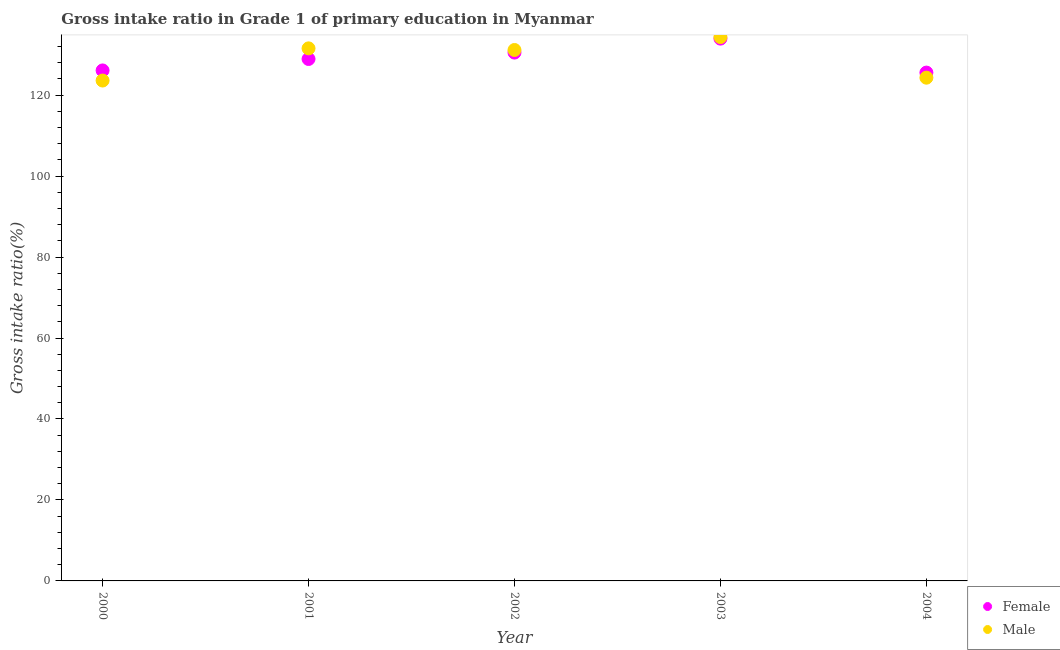What is the gross intake ratio(male) in 2002?
Keep it short and to the point. 131.15. Across all years, what is the maximum gross intake ratio(female)?
Ensure brevity in your answer.  133.96. Across all years, what is the minimum gross intake ratio(male)?
Offer a terse response. 123.61. In which year was the gross intake ratio(male) minimum?
Offer a very short reply. 2000. What is the total gross intake ratio(female) in the graph?
Offer a terse response. 645.09. What is the difference between the gross intake ratio(female) in 2000 and that in 2003?
Your answer should be very brief. -7.86. What is the difference between the gross intake ratio(male) in 2001 and the gross intake ratio(female) in 2002?
Make the answer very short. 1.04. What is the average gross intake ratio(male) per year?
Your answer should be very brief. 129. In the year 2000, what is the difference between the gross intake ratio(male) and gross intake ratio(female)?
Your answer should be compact. -2.5. What is the ratio of the gross intake ratio(female) in 2001 to that in 2003?
Provide a succinct answer. 0.96. Is the difference between the gross intake ratio(female) in 2001 and 2004 greater than the difference between the gross intake ratio(male) in 2001 and 2004?
Your response must be concise. No. What is the difference between the highest and the second highest gross intake ratio(female)?
Offer a very short reply. 3.45. What is the difference between the highest and the lowest gross intake ratio(male)?
Make the answer very short. 10.74. In how many years, is the gross intake ratio(male) greater than the average gross intake ratio(male) taken over all years?
Your answer should be compact. 3. Is the sum of the gross intake ratio(male) in 2000 and 2003 greater than the maximum gross intake ratio(female) across all years?
Give a very brief answer. Yes. Is the gross intake ratio(male) strictly greater than the gross intake ratio(female) over the years?
Provide a succinct answer. No. Is the gross intake ratio(male) strictly less than the gross intake ratio(female) over the years?
Make the answer very short. No. What is the difference between two consecutive major ticks on the Y-axis?
Keep it short and to the point. 20. Are the values on the major ticks of Y-axis written in scientific E-notation?
Give a very brief answer. No. Does the graph contain any zero values?
Your response must be concise. No. Does the graph contain grids?
Your answer should be very brief. No. How are the legend labels stacked?
Your answer should be compact. Vertical. What is the title of the graph?
Ensure brevity in your answer.  Gross intake ratio in Grade 1 of primary education in Myanmar. Does "Depositors" appear as one of the legend labels in the graph?
Your answer should be very brief. No. What is the label or title of the Y-axis?
Your answer should be very brief. Gross intake ratio(%). What is the Gross intake ratio(%) in Female in 2000?
Make the answer very short. 126.11. What is the Gross intake ratio(%) of Male in 2000?
Offer a very short reply. 123.61. What is the Gross intake ratio(%) in Female in 2001?
Ensure brevity in your answer.  128.93. What is the Gross intake ratio(%) of Male in 2001?
Your answer should be very brief. 131.56. What is the Gross intake ratio(%) of Female in 2002?
Ensure brevity in your answer.  130.52. What is the Gross intake ratio(%) in Male in 2002?
Provide a succinct answer. 131.15. What is the Gross intake ratio(%) in Female in 2003?
Ensure brevity in your answer.  133.96. What is the Gross intake ratio(%) in Male in 2003?
Your answer should be compact. 134.35. What is the Gross intake ratio(%) in Female in 2004?
Your response must be concise. 125.57. What is the Gross intake ratio(%) of Male in 2004?
Your response must be concise. 124.32. Across all years, what is the maximum Gross intake ratio(%) in Female?
Provide a succinct answer. 133.96. Across all years, what is the maximum Gross intake ratio(%) of Male?
Provide a short and direct response. 134.35. Across all years, what is the minimum Gross intake ratio(%) of Female?
Offer a very short reply. 125.57. Across all years, what is the minimum Gross intake ratio(%) of Male?
Provide a succinct answer. 123.61. What is the total Gross intake ratio(%) of Female in the graph?
Offer a terse response. 645.09. What is the total Gross intake ratio(%) in Male in the graph?
Provide a short and direct response. 644.98. What is the difference between the Gross intake ratio(%) of Female in 2000 and that in 2001?
Ensure brevity in your answer.  -2.83. What is the difference between the Gross intake ratio(%) of Male in 2000 and that in 2001?
Ensure brevity in your answer.  -7.95. What is the difference between the Gross intake ratio(%) of Female in 2000 and that in 2002?
Your answer should be very brief. -4.41. What is the difference between the Gross intake ratio(%) of Male in 2000 and that in 2002?
Give a very brief answer. -7.55. What is the difference between the Gross intake ratio(%) of Female in 2000 and that in 2003?
Offer a terse response. -7.86. What is the difference between the Gross intake ratio(%) of Male in 2000 and that in 2003?
Give a very brief answer. -10.74. What is the difference between the Gross intake ratio(%) in Female in 2000 and that in 2004?
Give a very brief answer. 0.53. What is the difference between the Gross intake ratio(%) in Male in 2000 and that in 2004?
Ensure brevity in your answer.  -0.71. What is the difference between the Gross intake ratio(%) of Female in 2001 and that in 2002?
Ensure brevity in your answer.  -1.58. What is the difference between the Gross intake ratio(%) of Male in 2001 and that in 2002?
Provide a short and direct response. 0.4. What is the difference between the Gross intake ratio(%) in Female in 2001 and that in 2003?
Provide a succinct answer. -5.03. What is the difference between the Gross intake ratio(%) in Male in 2001 and that in 2003?
Offer a terse response. -2.8. What is the difference between the Gross intake ratio(%) in Female in 2001 and that in 2004?
Your answer should be compact. 3.36. What is the difference between the Gross intake ratio(%) in Male in 2001 and that in 2004?
Your response must be concise. 7.24. What is the difference between the Gross intake ratio(%) of Female in 2002 and that in 2003?
Give a very brief answer. -3.45. What is the difference between the Gross intake ratio(%) in Male in 2002 and that in 2003?
Keep it short and to the point. -3.2. What is the difference between the Gross intake ratio(%) of Female in 2002 and that in 2004?
Keep it short and to the point. 4.94. What is the difference between the Gross intake ratio(%) in Male in 2002 and that in 2004?
Ensure brevity in your answer.  6.84. What is the difference between the Gross intake ratio(%) of Female in 2003 and that in 2004?
Your answer should be compact. 8.39. What is the difference between the Gross intake ratio(%) in Male in 2003 and that in 2004?
Offer a very short reply. 10.04. What is the difference between the Gross intake ratio(%) of Female in 2000 and the Gross intake ratio(%) of Male in 2001?
Your response must be concise. -5.45. What is the difference between the Gross intake ratio(%) in Female in 2000 and the Gross intake ratio(%) in Male in 2002?
Ensure brevity in your answer.  -5.05. What is the difference between the Gross intake ratio(%) in Female in 2000 and the Gross intake ratio(%) in Male in 2003?
Your answer should be compact. -8.25. What is the difference between the Gross intake ratio(%) in Female in 2000 and the Gross intake ratio(%) in Male in 2004?
Give a very brief answer. 1.79. What is the difference between the Gross intake ratio(%) of Female in 2001 and the Gross intake ratio(%) of Male in 2002?
Offer a very short reply. -2.22. What is the difference between the Gross intake ratio(%) of Female in 2001 and the Gross intake ratio(%) of Male in 2003?
Provide a succinct answer. -5.42. What is the difference between the Gross intake ratio(%) in Female in 2001 and the Gross intake ratio(%) in Male in 2004?
Your answer should be very brief. 4.62. What is the difference between the Gross intake ratio(%) of Female in 2002 and the Gross intake ratio(%) of Male in 2003?
Offer a very short reply. -3.84. What is the difference between the Gross intake ratio(%) in Female in 2002 and the Gross intake ratio(%) in Male in 2004?
Provide a succinct answer. 6.2. What is the difference between the Gross intake ratio(%) in Female in 2003 and the Gross intake ratio(%) in Male in 2004?
Provide a succinct answer. 9.65. What is the average Gross intake ratio(%) in Female per year?
Offer a terse response. 129.02. What is the average Gross intake ratio(%) in Male per year?
Give a very brief answer. 129. In the year 2000, what is the difference between the Gross intake ratio(%) in Female and Gross intake ratio(%) in Male?
Provide a succinct answer. 2.5. In the year 2001, what is the difference between the Gross intake ratio(%) in Female and Gross intake ratio(%) in Male?
Ensure brevity in your answer.  -2.62. In the year 2002, what is the difference between the Gross intake ratio(%) of Female and Gross intake ratio(%) of Male?
Your response must be concise. -0.64. In the year 2003, what is the difference between the Gross intake ratio(%) in Female and Gross intake ratio(%) in Male?
Provide a succinct answer. -0.39. In the year 2004, what is the difference between the Gross intake ratio(%) of Female and Gross intake ratio(%) of Male?
Your answer should be very brief. 1.26. What is the ratio of the Gross intake ratio(%) in Female in 2000 to that in 2001?
Offer a terse response. 0.98. What is the ratio of the Gross intake ratio(%) of Male in 2000 to that in 2001?
Give a very brief answer. 0.94. What is the ratio of the Gross intake ratio(%) of Female in 2000 to that in 2002?
Your answer should be very brief. 0.97. What is the ratio of the Gross intake ratio(%) of Male in 2000 to that in 2002?
Ensure brevity in your answer.  0.94. What is the ratio of the Gross intake ratio(%) in Female in 2000 to that in 2003?
Your response must be concise. 0.94. What is the ratio of the Gross intake ratio(%) in Male in 2000 to that in 2003?
Offer a very short reply. 0.92. What is the ratio of the Gross intake ratio(%) of Female in 2000 to that in 2004?
Offer a terse response. 1. What is the ratio of the Gross intake ratio(%) in Male in 2000 to that in 2004?
Offer a terse response. 0.99. What is the ratio of the Gross intake ratio(%) in Female in 2001 to that in 2002?
Provide a short and direct response. 0.99. What is the ratio of the Gross intake ratio(%) of Female in 2001 to that in 2003?
Your answer should be very brief. 0.96. What is the ratio of the Gross intake ratio(%) of Male in 2001 to that in 2003?
Your answer should be very brief. 0.98. What is the ratio of the Gross intake ratio(%) in Female in 2001 to that in 2004?
Your answer should be very brief. 1.03. What is the ratio of the Gross intake ratio(%) in Male in 2001 to that in 2004?
Provide a short and direct response. 1.06. What is the ratio of the Gross intake ratio(%) in Female in 2002 to that in 2003?
Your response must be concise. 0.97. What is the ratio of the Gross intake ratio(%) of Male in 2002 to that in 2003?
Keep it short and to the point. 0.98. What is the ratio of the Gross intake ratio(%) in Female in 2002 to that in 2004?
Give a very brief answer. 1.04. What is the ratio of the Gross intake ratio(%) of Male in 2002 to that in 2004?
Offer a terse response. 1.05. What is the ratio of the Gross intake ratio(%) in Female in 2003 to that in 2004?
Your answer should be compact. 1.07. What is the ratio of the Gross intake ratio(%) of Male in 2003 to that in 2004?
Your answer should be very brief. 1.08. What is the difference between the highest and the second highest Gross intake ratio(%) of Female?
Keep it short and to the point. 3.45. What is the difference between the highest and the second highest Gross intake ratio(%) in Male?
Offer a very short reply. 2.8. What is the difference between the highest and the lowest Gross intake ratio(%) in Female?
Give a very brief answer. 8.39. What is the difference between the highest and the lowest Gross intake ratio(%) of Male?
Give a very brief answer. 10.74. 